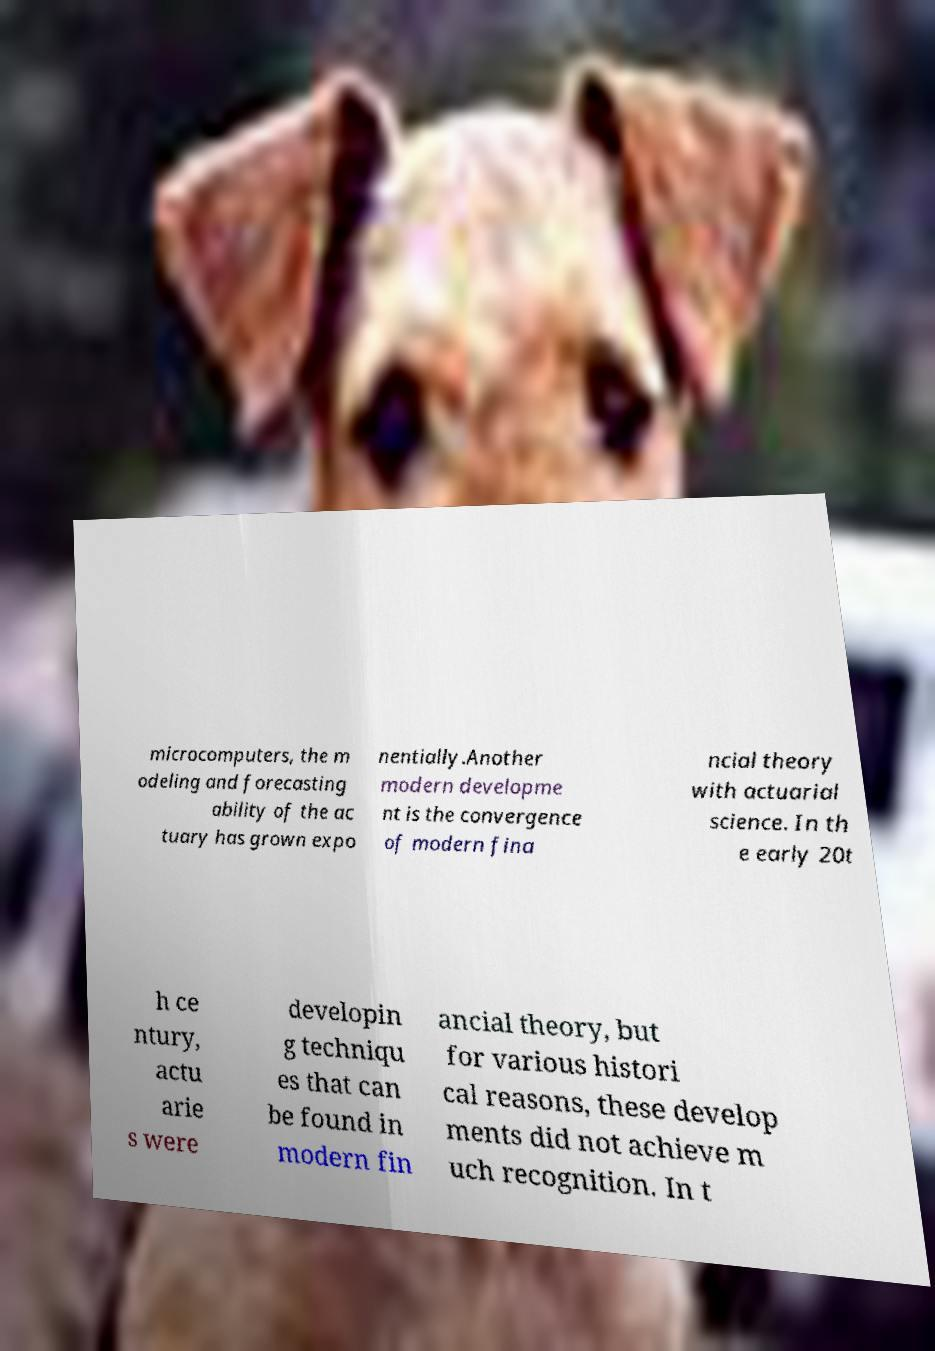Could you assist in decoding the text presented in this image and type it out clearly? microcomputers, the m odeling and forecasting ability of the ac tuary has grown expo nentially.Another modern developme nt is the convergence of modern fina ncial theory with actuarial science. In th e early 20t h ce ntury, actu arie s were developin g techniqu es that can be found in modern fin ancial theory, but for various histori cal reasons, these develop ments did not achieve m uch recognition. In t 